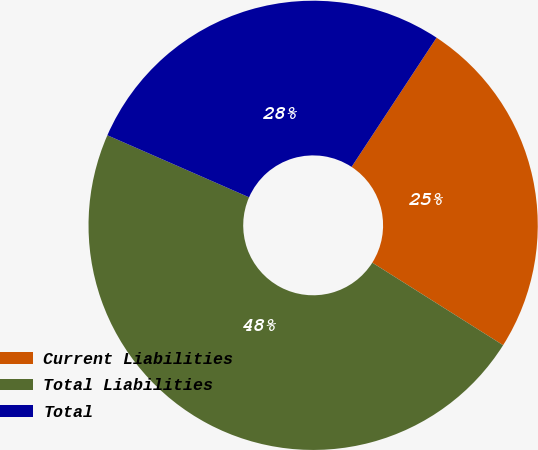Convert chart to OTSL. <chart><loc_0><loc_0><loc_500><loc_500><pie_chart><fcel>Current Liabilities<fcel>Total Liabilities<fcel>Total<nl><fcel>24.7%<fcel>47.61%<fcel>27.69%<nl></chart> 